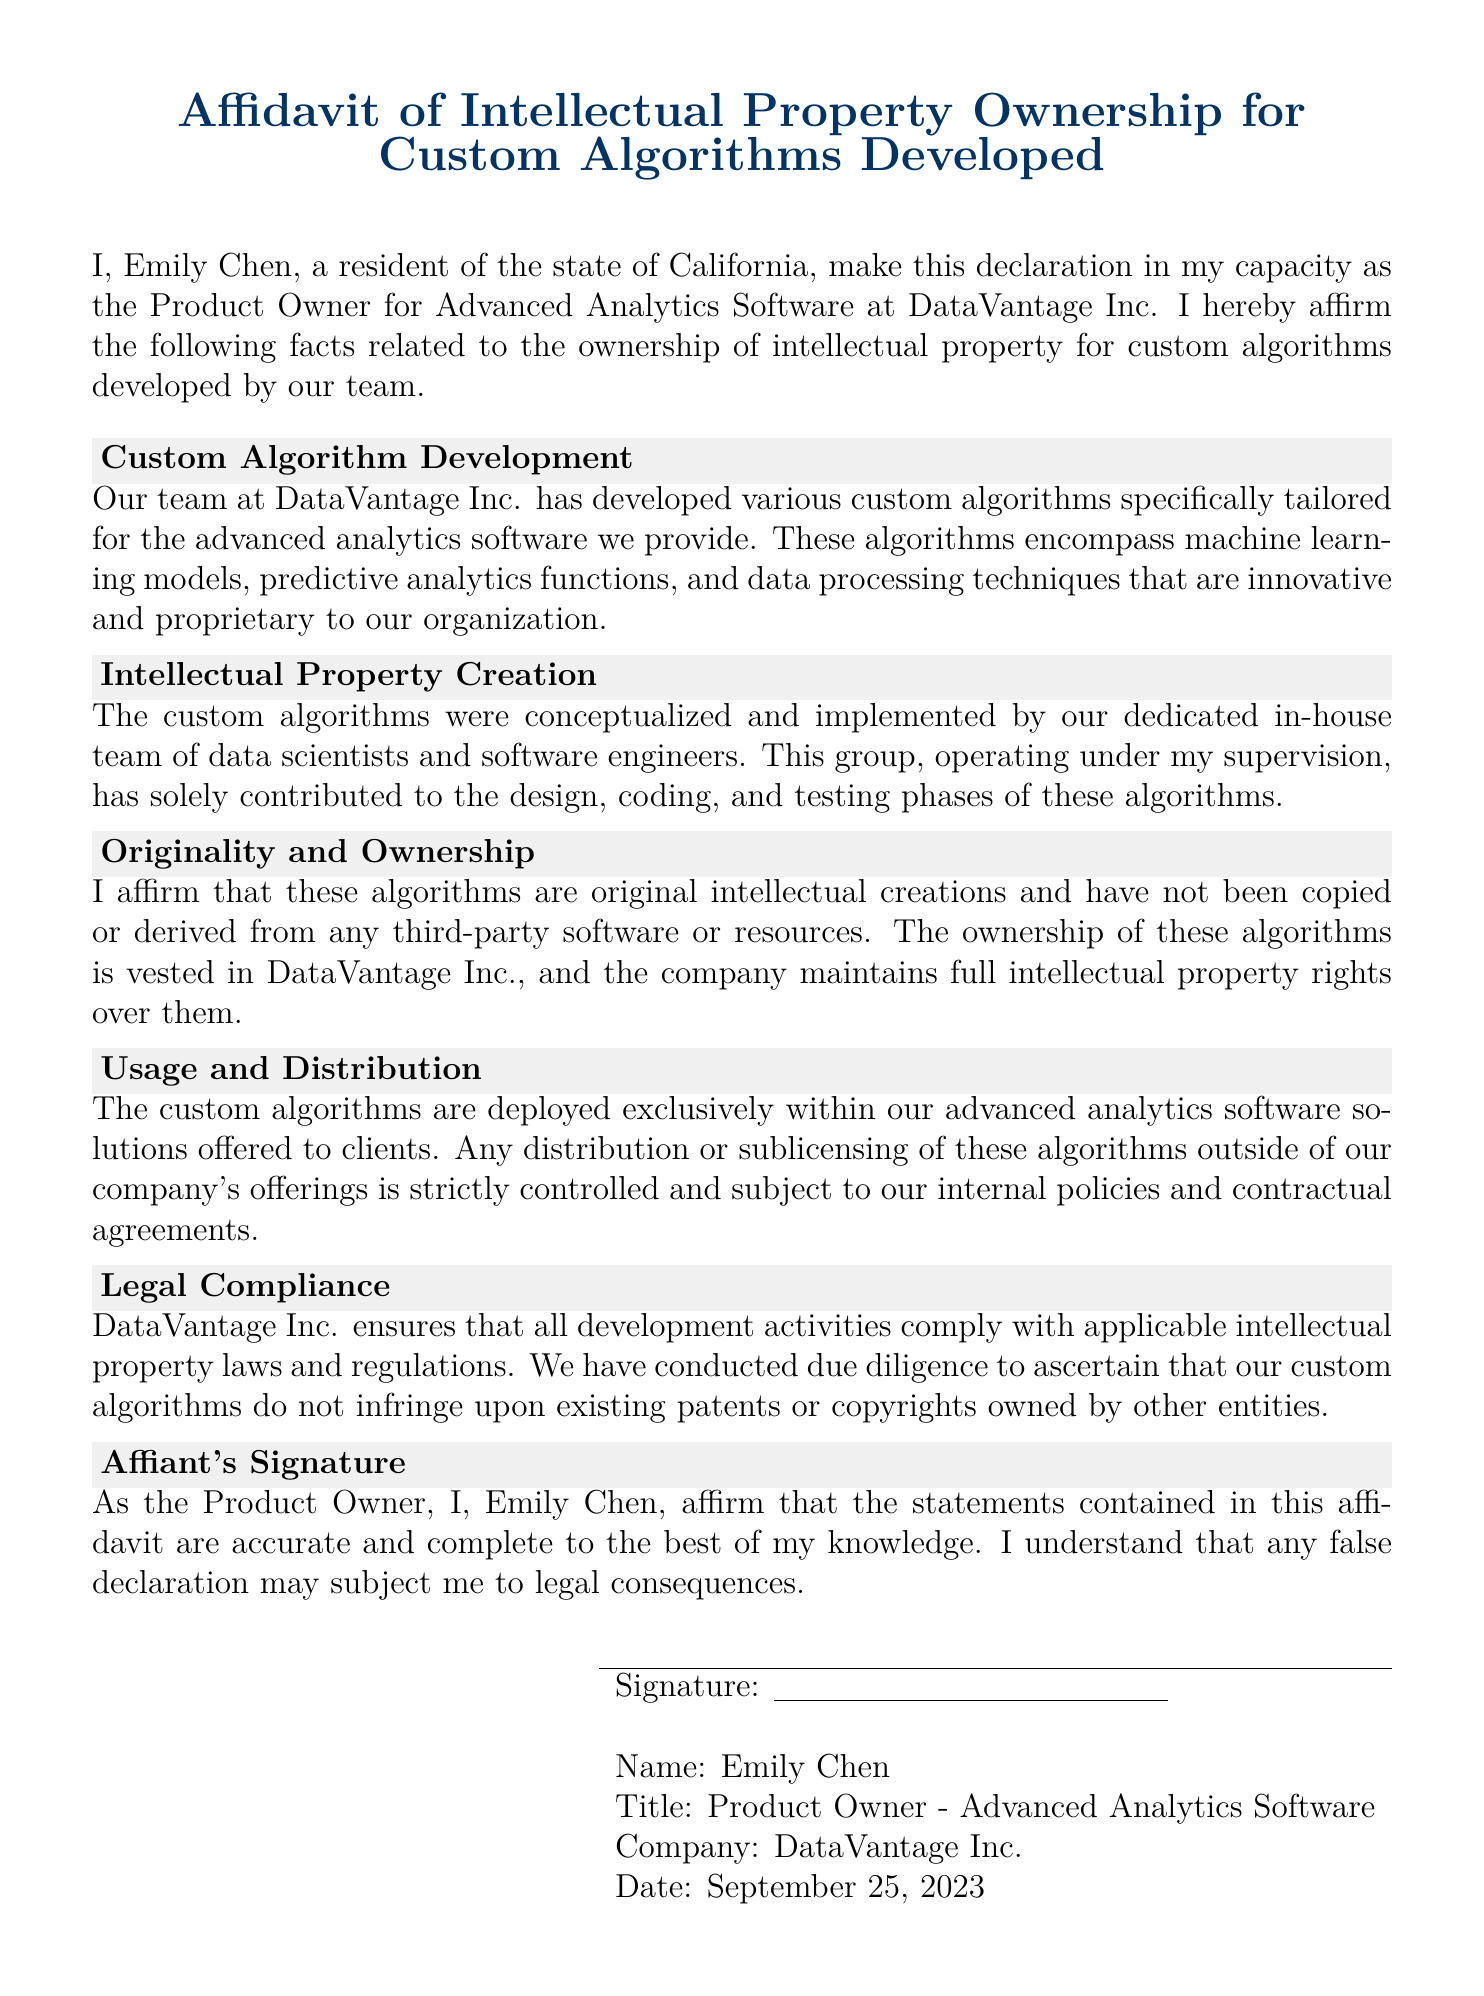What is the name of the affiant? The affiant's name is stated upfront in the document as Emily Chen.
Answer: Emily Chen What is the title of Emily Chen? The title is mentioned in the context where Emily Chen's position is described.
Answer: Product Owner - Advanced Analytics Software What is the company name? The company name is explicitly stated in the affiant's introduction.
Answer: DataVantage Inc On what date was the affidavit signed? The signing date is provided in the signature block at the end of the document.
Answer: September 25, 2023 What state does the affiant reside in? The affiant's residence state is mentioned in the opening declaration.
Answer: California What kind of algorithms were developed? The document lists specific types of algorithms developed by the team.
Answer: Custom algorithms Who was responsible for conceptualizing the algorithms? The document attributes the conceptualization of the algorithms to a specific group.
Answer: In-house team of data scientists and software engineers What is stated about the originality of the algorithms? A specific claim is made regarding the originality of the algorithms in the document.
Answer: Original intellectual creations What does DataVantage Inc. ensure regarding legal compliance? The document indicates a commitment made by the company related to legal matters.
Answer: Compliance with applicable intellectual property laws and regulations What is prohibited regarding the distribution of algorithms? There’s a policy mentioned about how distribution is handled.
Answer: Strictly controlled and subject to internal policies 